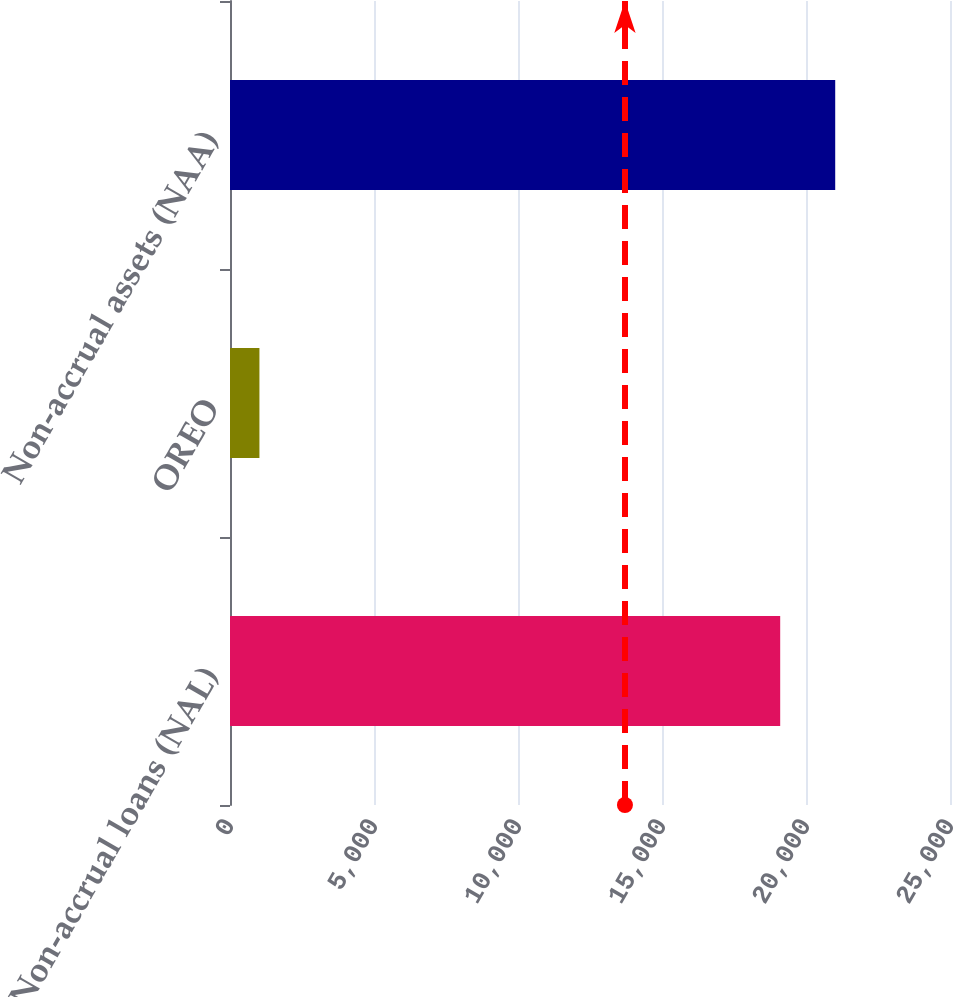<chart> <loc_0><loc_0><loc_500><loc_500><bar_chart><fcel>Non-accrual loans (NAL)<fcel>OREO<fcel>Non-accrual assets (NAA)<nl><fcel>19104<fcel>1022<fcel>21014.4<nl></chart> 